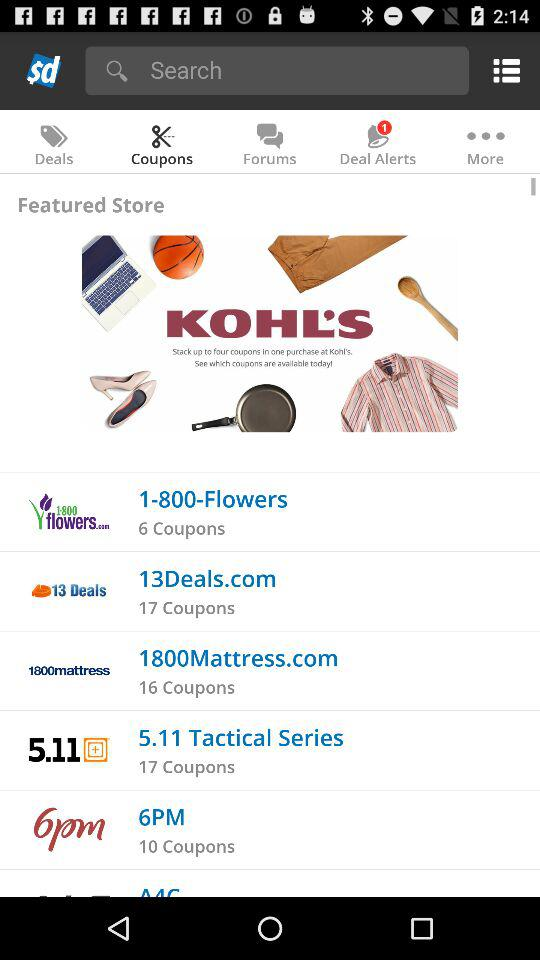How many notifications are there for deal alerts? There is 1 notification for deal alerts. 